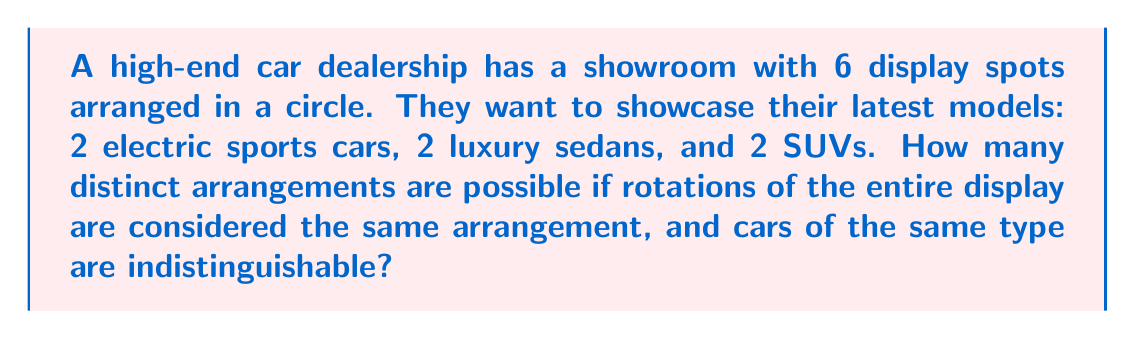Can you answer this question? Let's approach this problem using combinatorial group theory:

1) First, we need to consider the total number of ways to arrange 6 cars:
   $6! = 720$

2) However, we need to account for the following:
   a) Rotations are considered the same arrangement (cyclic group of order 6)
   b) The 2 electric sports cars are indistinguishable
   c) The 2 luxury sedans are indistinguishable
   d) The 2 SUVs are indistinguishable

3) To account for rotations, we divide by 6:
   $\frac{720}{6} = 120$

4) To account for the indistinguishable cars, we need to divide by $2!$ for each pair:
   $\frac{120}{2! \cdot 2! \cdot 2!} = \frac{120}{8} = 15$

5) This can be expressed using the cycle index of the dihedral group $D_6$ acting on 6 objects:

   $$Z(D_6) = \frac{1}{12}(x_1^6 + x_2^3 + 2x_3^2 + 2x_6 + 3x_1^2x_2^2 + 3x_1^4x_2)$$

6) Applying Pólya's enumeration theorem with the cycle index and using the pattern inventory $(a+b+c)^6$ where $a$, $b$, and $c$ represent the three types of cars, we get:

   $$\frac{1}{12}((a+b+c)^6 + (a^2+b^2+c^2)^3 + 2(a^3+b^3+c^3)^2 + 2(a^6+b^6+c^6) + 3(a+b+c)^2(a^2+b^2+c^2)^2 + 3(a+b+c)^4(a^2+b^2+c^2))$$

7) Extracting the coefficient of $a^2b^2c^2$ from this polynomial gives us the number of distinct arrangements.

8) This coefficient turns out to be 15, confirming our earlier calculation.
Answer: 15 distinct arrangements 